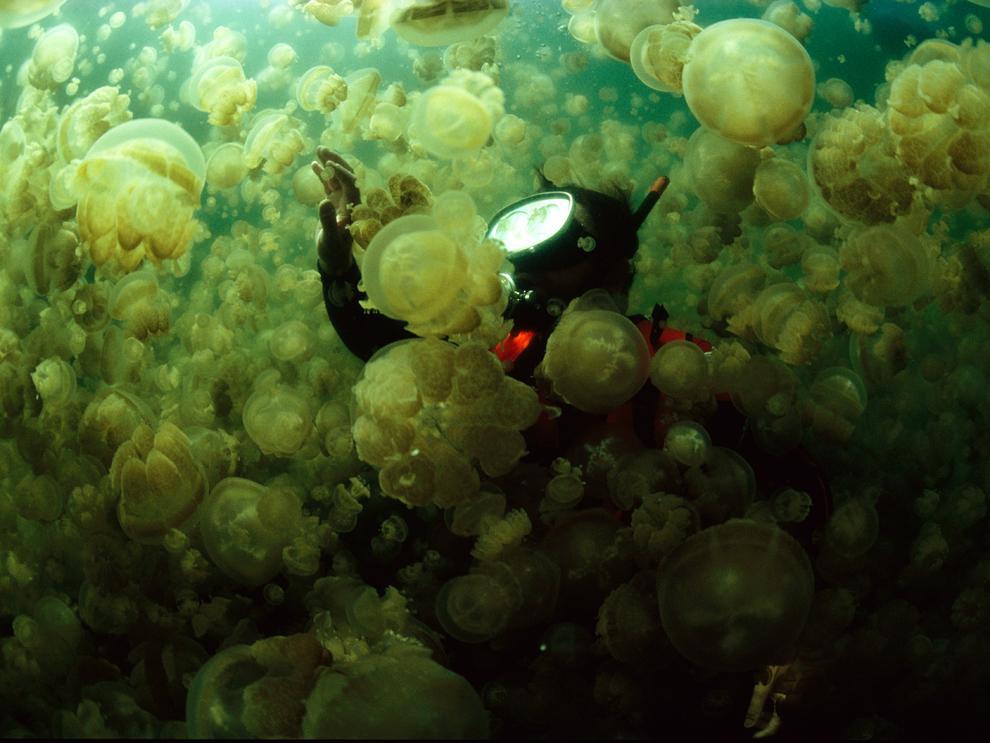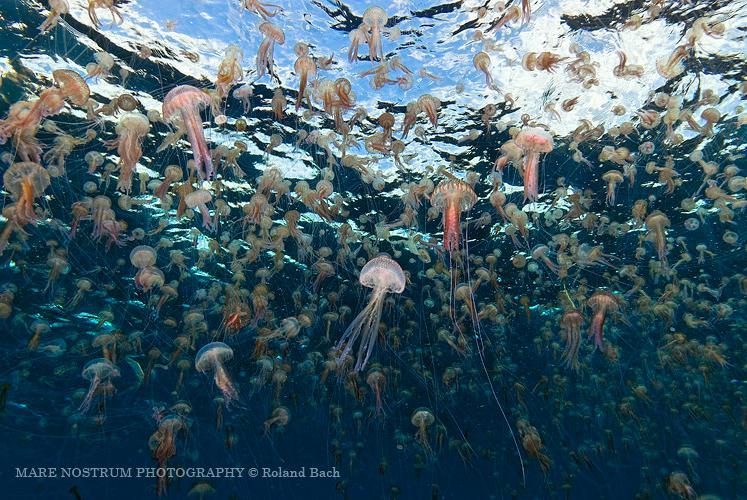The first image is the image on the left, the second image is the image on the right. Considering the images on both sides, is "The rippled surface of the water is visible in one of the images." valid? Answer yes or no. Yes. 